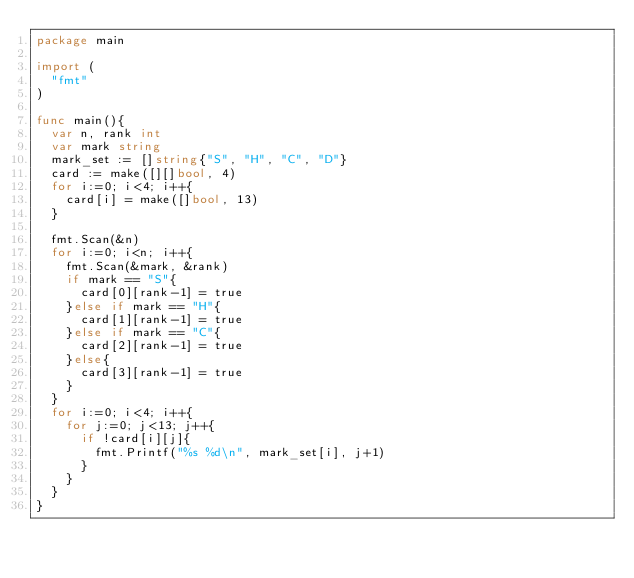Convert code to text. <code><loc_0><loc_0><loc_500><loc_500><_Go_>package main

import (
	"fmt"
)

func main(){
	var n, rank int
	var mark string
	mark_set := []string{"S", "H", "C", "D"}
	card := make([][]bool, 4)
	for i:=0; i<4; i++{
		card[i] = make([]bool, 13)
	}

	fmt.Scan(&n)
	for i:=0; i<n; i++{
		fmt.Scan(&mark, &rank)
		if mark == "S"{
			card[0][rank-1] = true
		}else if mark == "H"{
			card[1][rank-1] = true
		}else if mark == "C"{
			card[2][rank-1] = true
		}else{
			card[3][rank-1] = true
		}
	}
	for i:=0; i<4; i++{
		for j:=0; j<13; j++{
			if !card[i][j]{
				fmt.Printf("%s %d\n", mark_set[i], j+1)
			}
		}
	}
}
</code> 